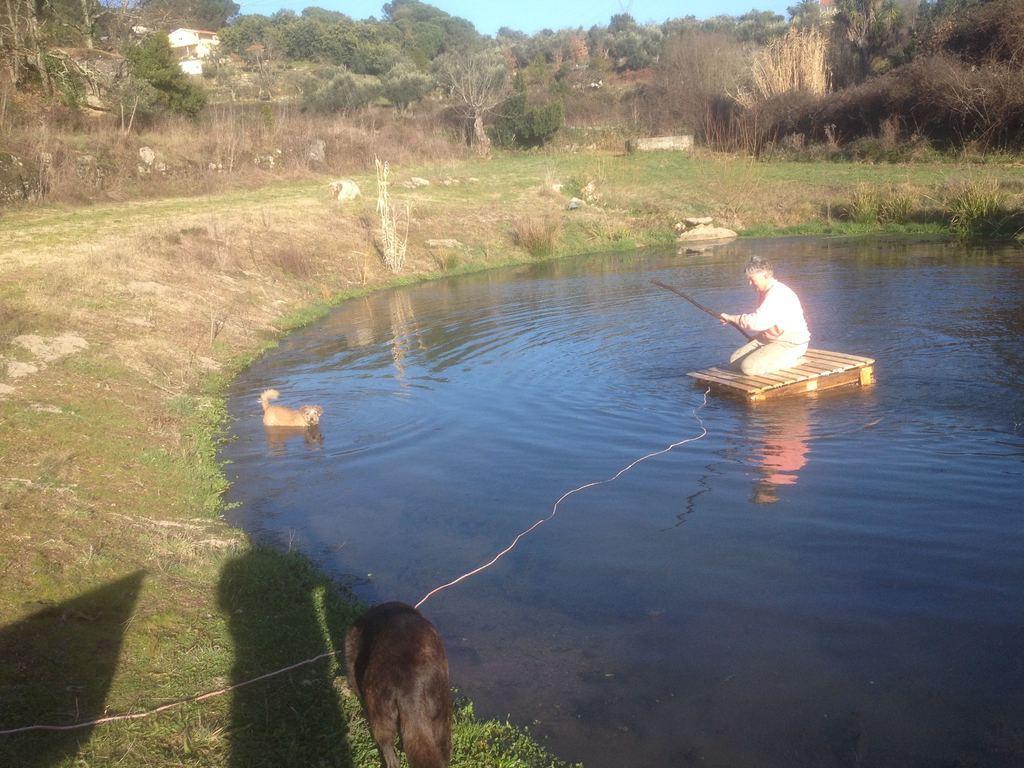Please provide a concise description of this image. In this picture we can see a person holding a fishing rod and sitting on a platform, two dogs where a dog is in water, grass, trees and in the background we can see the sky. 